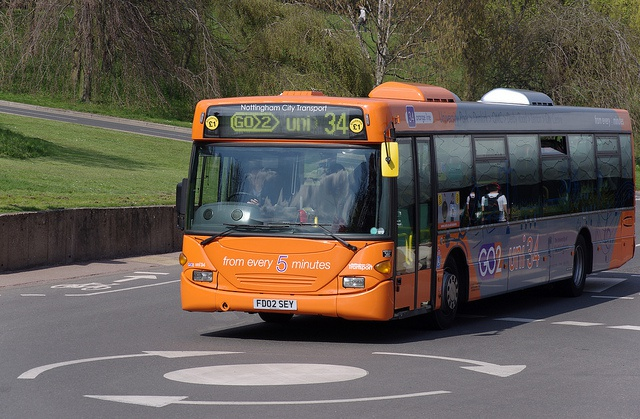Describe the objects in this image and their specific colors. I can see bus in black, gray, and orange tones, people in black, gray, darkgray, and blue tones, people in black, gray, blue, and darkgray tones, backpack in black, blue, gray, and darkgray tones, and people in black, gray, darkgray, and maroon tones in this image. 